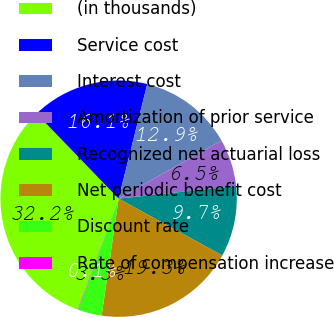Convert chart. <chart><loc_0><loc_0><loc_500><loc_500><pie_chart><fcel>(in thousands)<fcel>Service cost<fcel>Interest cost<fcel>Amortization of prior service<fcel>Recognized net actuarial loss<fcel>Net periodic benefit cost<fcel>Discount rate<fcel>Rate of compensation increase<nl><fcel>32.16%<fcel>16.11%<fcel>12.9%<fcel>6.48%<fcel>9.69%<fcel>19.32%<fcel>3.27%<fcel>0.06%<nl></chart> 